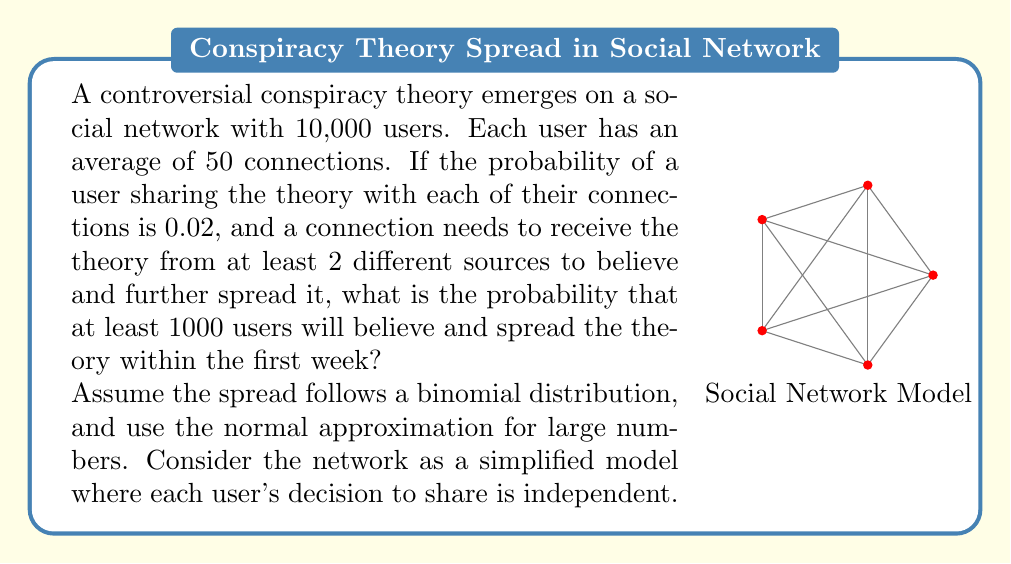Give your solution to this math problem. Let's approach this step-by-step:

1) First, we need to calculate the probability of a single user believing and spreading the theory. This requires at least 2 of their connections to share the theory with them.

2) The probability of a connection sharing is 0.02. The probability of not sharing is 1 - 0.02 = 0.98.

3) For a user with 50 connections, the probability of exactly k connections sharing is given by the binomial probability:

   $$P(X = k) = \binom{50}{k} (0.02)^k (0.98)^{50-k}$$

4) We need the probability of 2 or more connections sharing. This is easier to calculate as 1 minus the probability of 0 or 1 connection sharing:

   $$P(X \geq 2) = 1 - [P(X = 0) + P(X = 1)]$$
   
   $$= 1 - [\binom{50}{0} (0.02)^0 (0.98)^{50} + \binom{50}{1} (0.02)^1 (0.98)^{49}]$$
   
   $$= 1 - [0.3660 + 0.3731] = 0.2609$$

5) So, each user has a 0.2609 probability of believing and spreading the theory.

6) Now, for 10,000 users, we can use the normal approximation to the binomial distribution. The mean (μ) and standard deviation (σ) are:

   $$\mu = np = 10000 * 0.2609 = 2609$$
   $$\sigma = \sqrt{np(1-p)} = \sqrt{10000 * 0.2609 * 0.7391} = 43.91$$

7) We want the probability of at least 1000 users believing and spreading. Using the z-score:

   $$z = \frac{1000 - 2609}{43.91} = -36.64$$

8) The probability is the area to the right of this z-score on a standard normal distribution. This is extremely close to 1 (>0.9999).
Answer: $>0.9999$ 